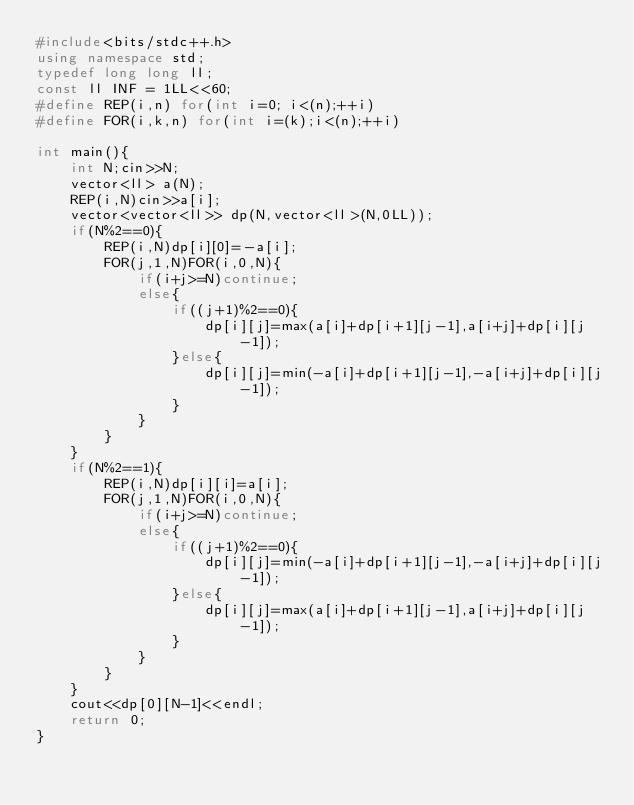Convert code to text. <code><loc_0><loc_0><loc_500><loc_500><_C++_>#include<bits/stdc++.h>
using namespace std;
typedef long long ll;
const ll INF = 1LL<<60;
#define REP(i,n) for(int i=0; i<(n);++i)
#define FOR(i,k,n) for(int i=(k);i<(n);++i)

int main(){
    int N;cin>>N;
    vector<ll> a(N);
    REP(i,N)cin>>a[i];
    vector<vector<ll>> dp(N,vector<ll>(N,0LL));
    if(N%2==0){
        REP(i,N)dp[i][0]=-a[i];
        FOR(j,1,N)FOR(i,0,N){
            if(i+j>=N)continue;
            else{
                if((j+1)%2==0){
                    dp[i][j]=max(a[i]+dp[i+1][j-1],a[i+j]+dp[i][j-1]);
                }else{
                    dp[i][j]=min(-a[i]+dp[i+1][j-1],-a[i+j]+dp[i][j-1]);
                }
            }
        }
    }
    if(N%2==1){
        REP(i,N)dp[i][i]=a[i];
        FOR(j,1,N)FOR(i,0,N){
            if(i+j>=N)continue;
            else{
                if((j+1)%2==0){
                    dp[i][j]=min(-a[i]+dp[i+1][j-1],-a[i+j]+dp[i][j-1]);
                }else{
                    dp[i][j]=max(a[i]+dp[i+1][j-1],a[i+j]+dp[i][j-1]);
                }
            }
        }
    }
    cout<<dp[0][N-1]<<endl;
    return 0;
}</code> 